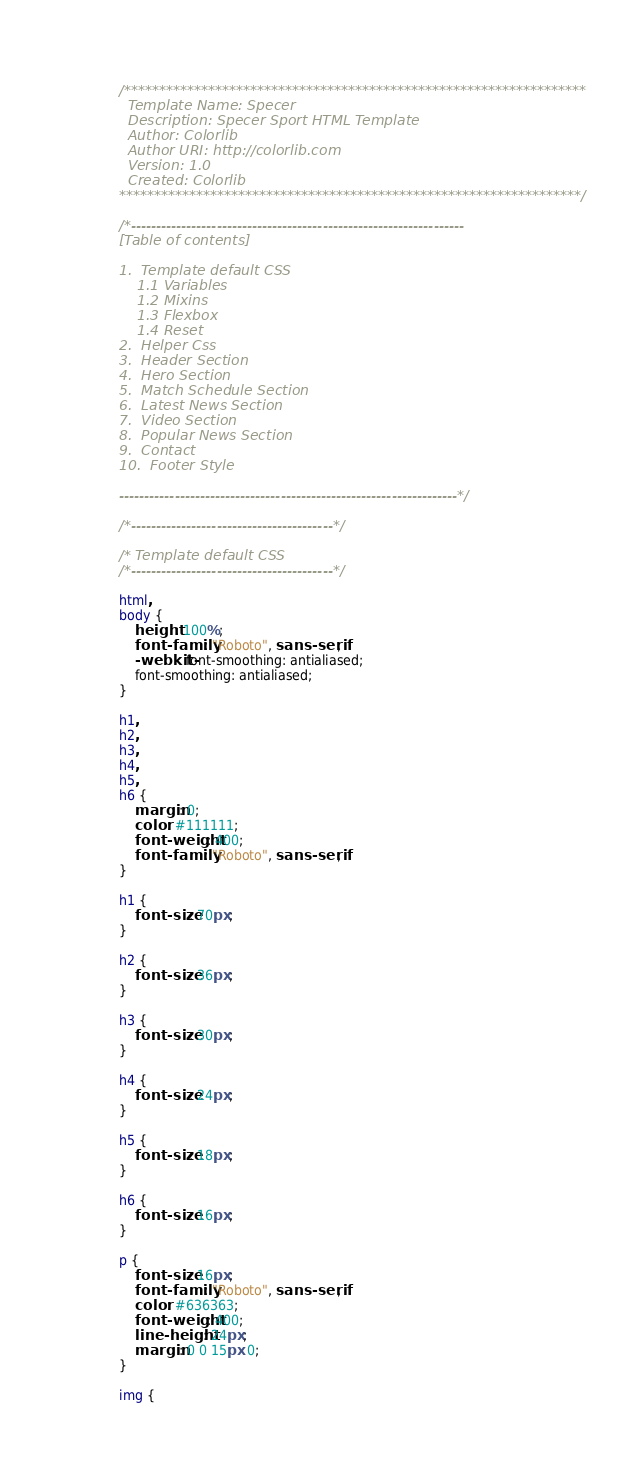<code> <loc_0><loc_0><loc_500><loc_500><_CSS_>/******************************************************************
  Template Name: Specer
  Description: Specer Sport HTML Template
  Author: Colorlib
  Author URI: http://colorlib.com
  Version: 1.0
  Created: Colorlib
******************************************************************/

/*------------------------------------------------------------------
[Table of contents]

1.  Template default CSS
	1.1	Variables
	1.2	Mixins
	1.3	Flexbox
	1.4	Reset
2.  Helper Css
3.  Header Section
4.  Hero Section
5.  Match Schedule Section
6.  Latest News Section
7.  Video Section
8.  Popular News Section
9.  Contact
10.  Footer Style

-------------------------------------------------------------------*/

/*----------------------------------------*/

/* Template default CSS
/*----------------------------------------*/

html,
body {
	height: 100%;
	font-family: "Roboto", sans-serif;
	-webkit-font-smoothing: antialiased;
	font-smoothing: antialiased;
}

h1,
h2,
h3,
h4,
h5,
h6 {
	margin: 0;
	color: #111111;
	font-weight: 400;
	font-family: "Roboto", sans-serif;
}

h1 {
	font-size: 70px;
}

h2 {
	font-size: 36px;
}

h3 {
	font-size: 30px;
}

h4 {
	font-size: 24px;
}

h5 {
	font-size: 18px;
}

h6 {
	font-size: 16px;
}

p {
	font-size: 16px;
	font-family: "Roboto", sans-serif;
	color: #636363;
	font-weight: 400;
	line-height: 24px;
	margin: 0 0 15px 0;
}

img {</code> 